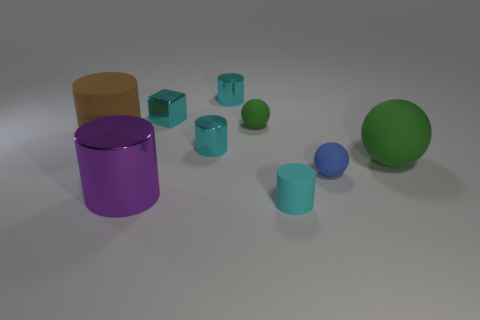What number of metal things are either cylinders or tiny red cylinders?
Your answer should be compact. 3. The block is what size?
Ensure brevity in your answer.  Small. How many objects are either tiny green metal cylinders or metal cylinders that are left of the tiny blue matte thing?
Keep it short and to the point. 3. What number of other objects are the same color as the cube?
Provide a succinct answer. 3. Does the cyan metal block have the same size as the green matte object that is on the left side of the tiny cyan matte object?
Offer a very short reply. Yes. There is a cyan shiny thing that is in front of the cube; is its size the same as the brown thing?
Give a very brief answer. No. What number of other things are there of the same material as the large brown cylinder
Keep it short and to the point. 4. Is the number of rubber cylinders that are in front of the big matte sphere the same as the number of green rubber balls to the left of the purple metal cylinder?
Your answer should be compact. No. There is a large cylinder in front of the small metallic cylinder that is on the left side of the small cyan object that is behind the small cyan cube; what color is it?
Your answer should be compact. Purple. What is the shape of the green thing left of the small blue ball?
Your answer should be compact. Sphere. 